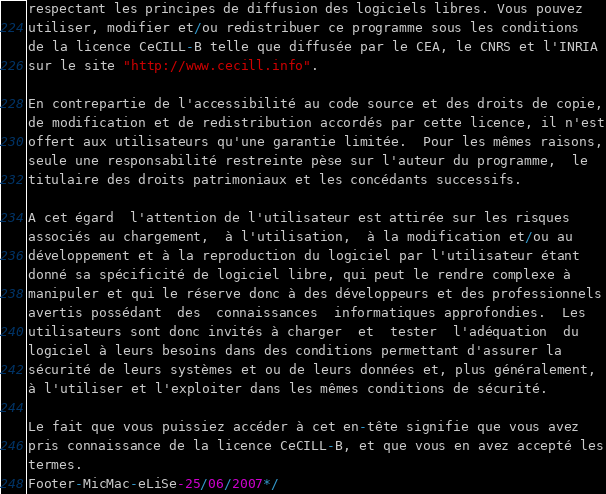Convert code to text. <code><loc_0><loc_0><loc_500><loc_500><_C_>respectant les principes de diffusion des logiciels libres. Vous pouvez
utiliser, modifier et/ou redistribuer ce programme sous les conditions
de la licence CeCILL-B telle que diffusée par le CEA, le CNRS et l'INRIA 
sur le site "http://www.cecill.info".

En contrepartie de l'accessibilité au code source et des droits de copie,
de modification et de redistribution accordés par cette licence, il n'est
offert aux utilisateurs qu'une garantie limitée.  Pour les mêmes raisons,
seule une responsabilité restreinte pèse sur l'auteur du programme,  le
titulaire des droits patrimoniaux et les concédants successifs.

A cet égard  l'attention de l'utilisateur est attirée sur les risques
associés au chargement,  à l'utilisation,  à la modification et/ou au
développement et à la reproduction du logiciel par l'utilisateur étant 
donné sa spécificité de logiciel libre, qui peut le rendre complexe à 
manipuler et qui le réserve donc à des développeurs et des professionnels
avertis possédant  des  connaissances  informatiques approfondies.  Les
utilisateurs sont donc invités à charger  et  tester  l'adéquation  du
logiciel à leurs besoins dans des conditions permettant d'assurer la
sécurité de leurs systèmes et ou de leurs données et, plus généralement, 
à l'utiliser et l'exploiter dans les mêmes conditions de sécurité. 

Le fait que vous puissiez accéder à cet en-tête signifie que vous avez 
pris connaissance de la licence CeCILL-B, et que vous en avez accepté les
termes.
Footer-MicMac-eLiSe-25/06/2007*/
</code> 